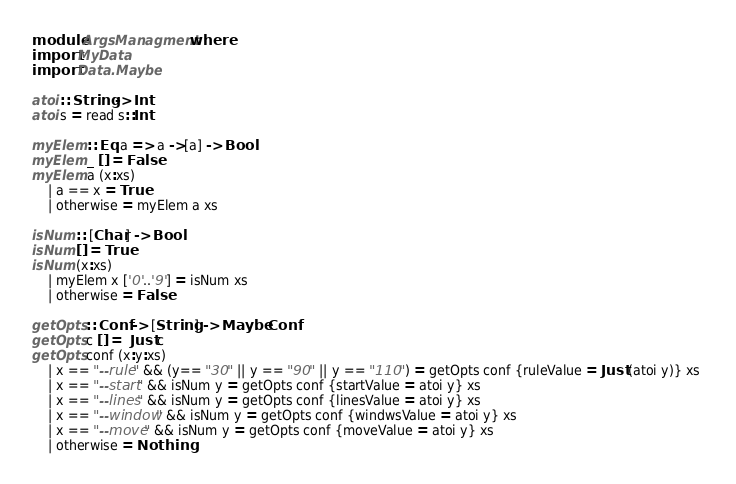<code> <loc_0><loc_0><loc_500><loc_500><_Haskell_>module ArgsManagment where
import MyData
import Data.Maybe

atoi :: String -> Int
atoi s = read s::Int 

myElem :: Eq a => a ->[a] -> Bool 
myElem _ [] = False 
myElem a (x:xs)
    | a == x = True 
    | otherwise = myElem a xs

isNum :: [Char] -> Bool 
isNum [] = True 
isNum (x:xs)
    | myElem x ['0'..'9'] = isNum xs
    | otherwise = False 

getOpts :: Conf -> [String] -> Maybe Conf
getOpts c [] =  Just c 
getOpts conf (x:y:xs) 
    | x == "--rule" && (y== "30" || y == "90" || y == "110") = getOpts conf {ruleValue = Just (atoi y)} xs 
    | x == "--start" && isNum y = getOpts conf {startValue = atoi y} xs
    | x == "--lines" && isNum y = getOpts conf {linesValue = atoi y} xs
    | x == "--window" && isNum y = getOpts conf {windwsValue = atoi y} xs
    | x == "--move" && isNum y = getOpts conf {moveValue = atoi y} xs
    | otherwise = Nothing </code> 